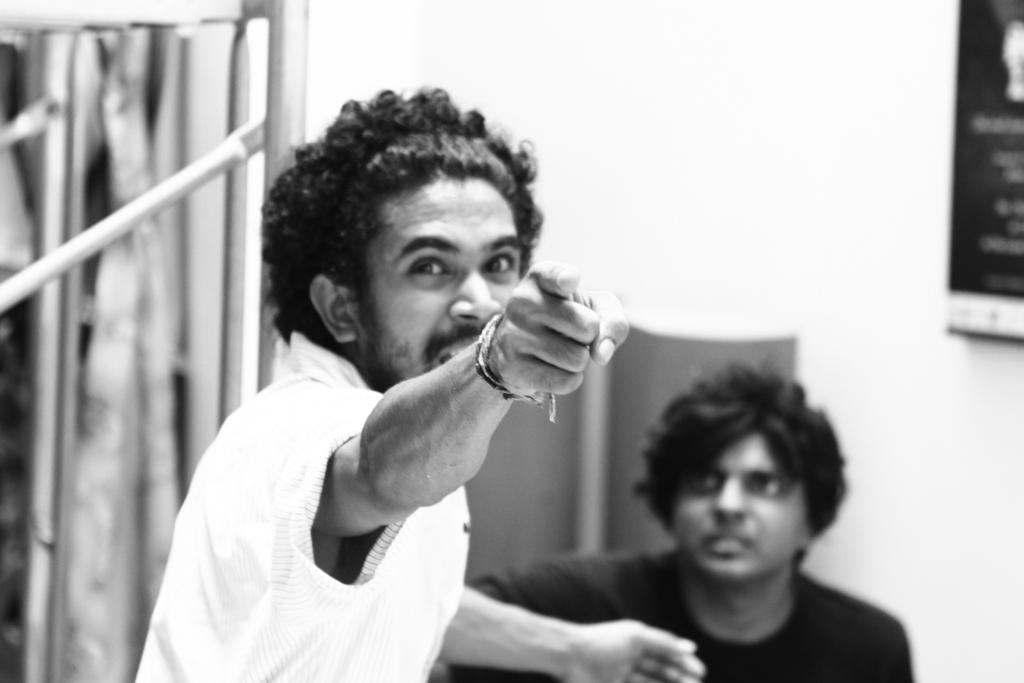How many people are in the image? There are two men in the image. What can be seen in the background of the image? There are metal rods and a frame on the wall in the background of the image. What is the color scheme of the image? The image is in black and white. Where is the faucet located in the image? There is no faucet present in the image. What time of day is depicted in the image? The image is in black and white, so it is not possible to determine the time of day from the image. 